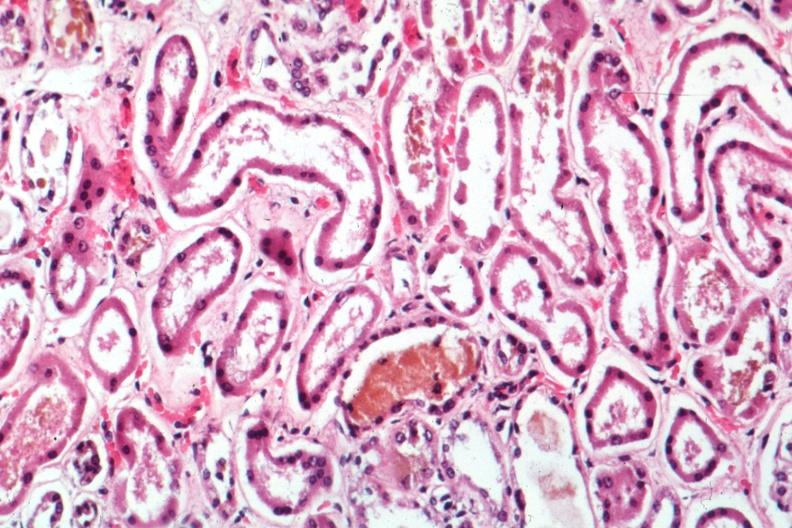what does this image show?
Answer the question using a single word or phrase. Mad dilated tubules with missing and pyknotic nuclei and bile in one quite good 